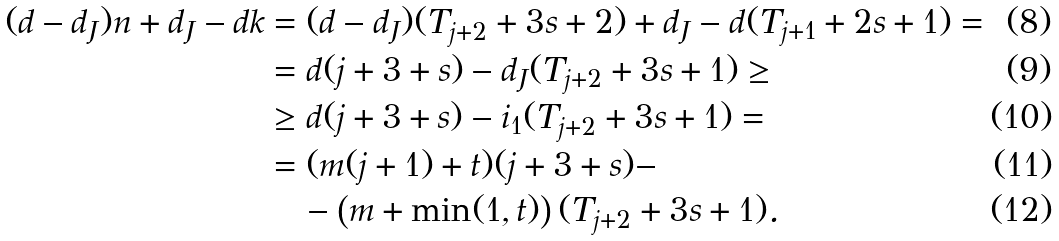<formula> <loc_0><loc_0><loc_500><loc_500>( d - d _ { J } ) n + d _ { J } - d k & = ( d - d _ { J } ) ( T _ { j + 2 } + 3 s + 2 ) + d _ { J } - d ( T _ { j + 1 } + 2 s + 1 ) = \\ & = d ( j + 3 + s ) - d _ { J } ( T _ { j + 2 } + 3 s + 1 ) \geq \\ & \geq d ( j + 3 + s ) - i _ { 1 } ( T _ { j + 2 } + 3 s + 1 ) = \\ & = ( m ( j + 1 ) + t ) ( j + 3 + s ) - \\ & \quad - \left ( m + \min ( 1 , t ) \right ) ( T _ { j + 2 } + 3 s + 1 ) .</formula> 